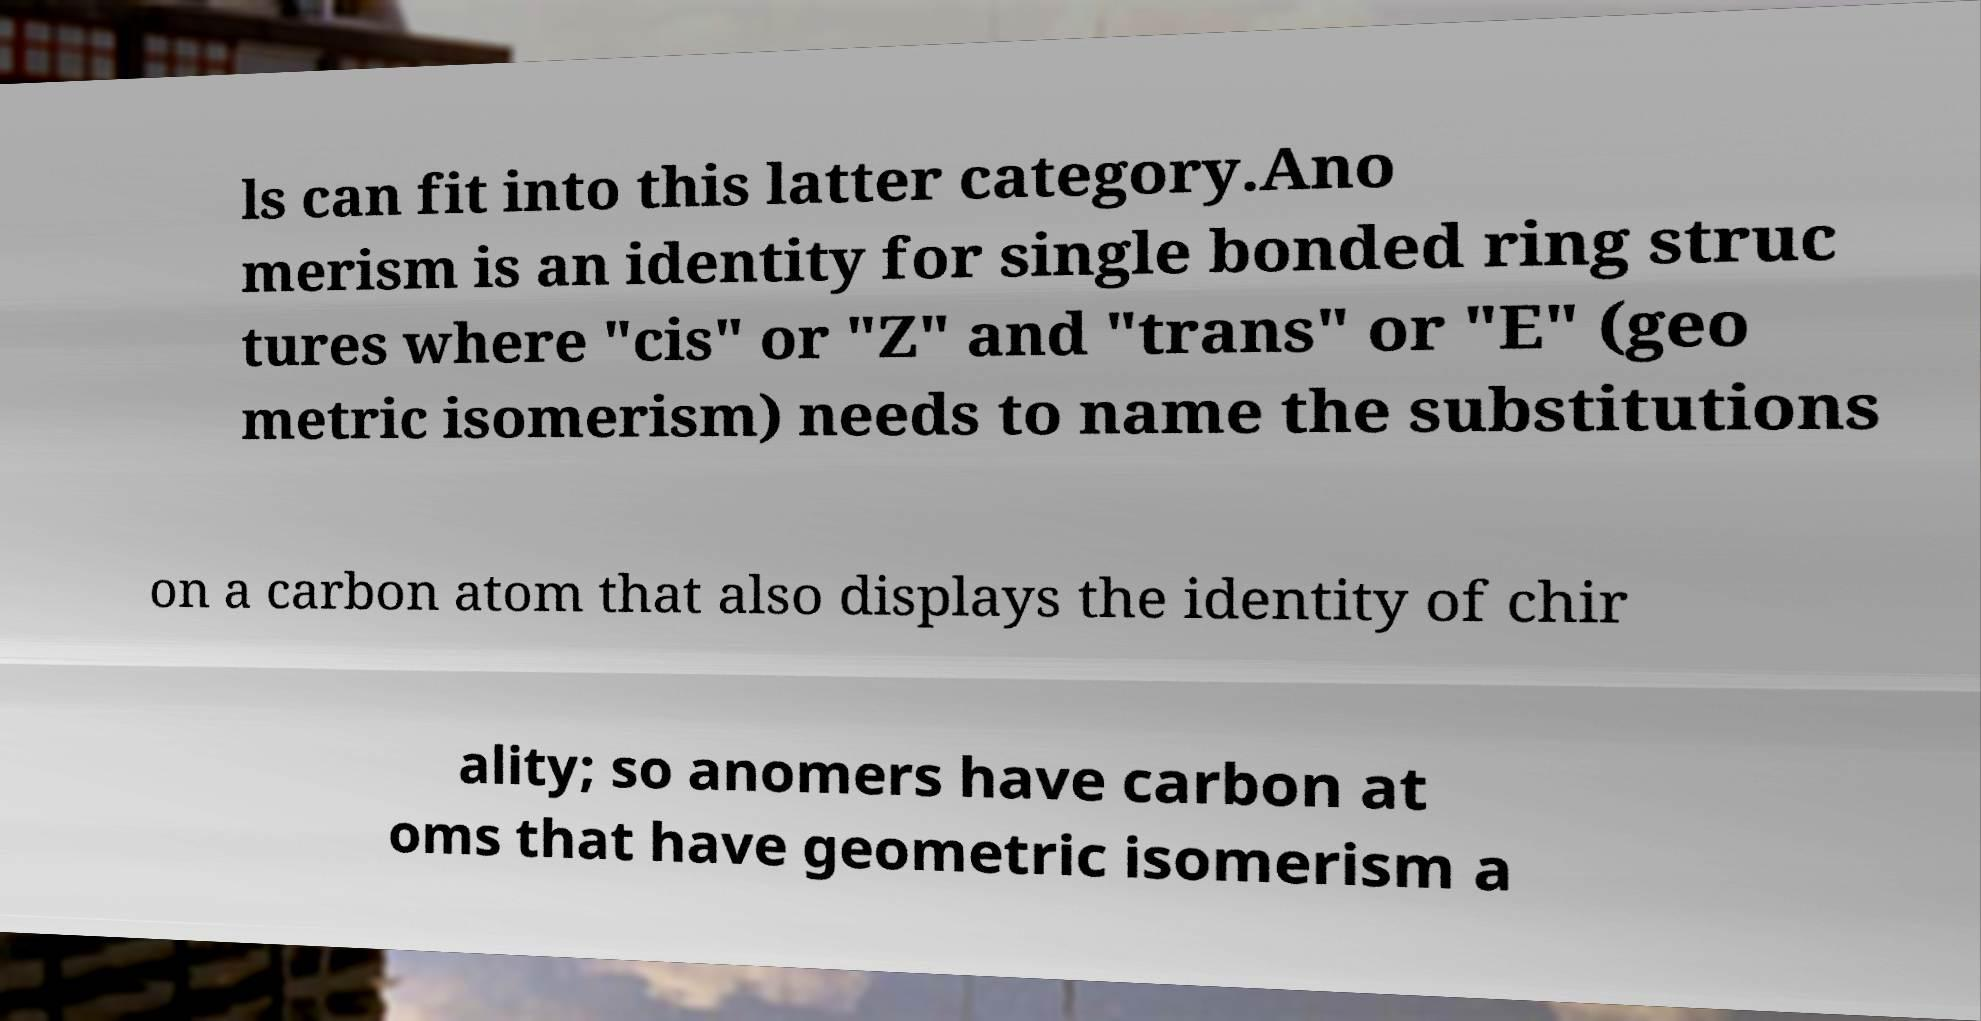Could you assist in decoding the text presented in this image and type it out clearly? ls can fit into this latter category.Ano merism is an identity for single bonded ring struc tures where "cis" or "Z" and "trans" or "E" (geo metric isomerism) needs to name the substitutions on a carbon atom that also displays the identity of chir ality; so anomers have carbon at oms that have geometric isomerism a 